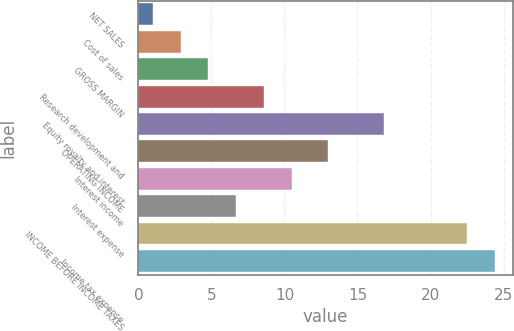Convert chart. <chart><loc_0><loc_0><loc_500><loc_500><bar_chart><fcel>NET SALES<fcel>Cost of sales<fcel>GROSS MARGIN<fcel>Research development and<fcel>Equity royalty and interest<fcel>OPERATING INCOME<fcel>Interest income<fcel>Interest expense<fcel>INCOME BEFORE INCOME TAXES<fcel>Income tax expense<nl><fcel>1<fcel>2.9<fcel>4.8<fcel>8.6<fcel>16.8<fcel>13<fcel>10.5<fcel>6.7<fcel>22.5<fcel>24.4<nl></chart> 